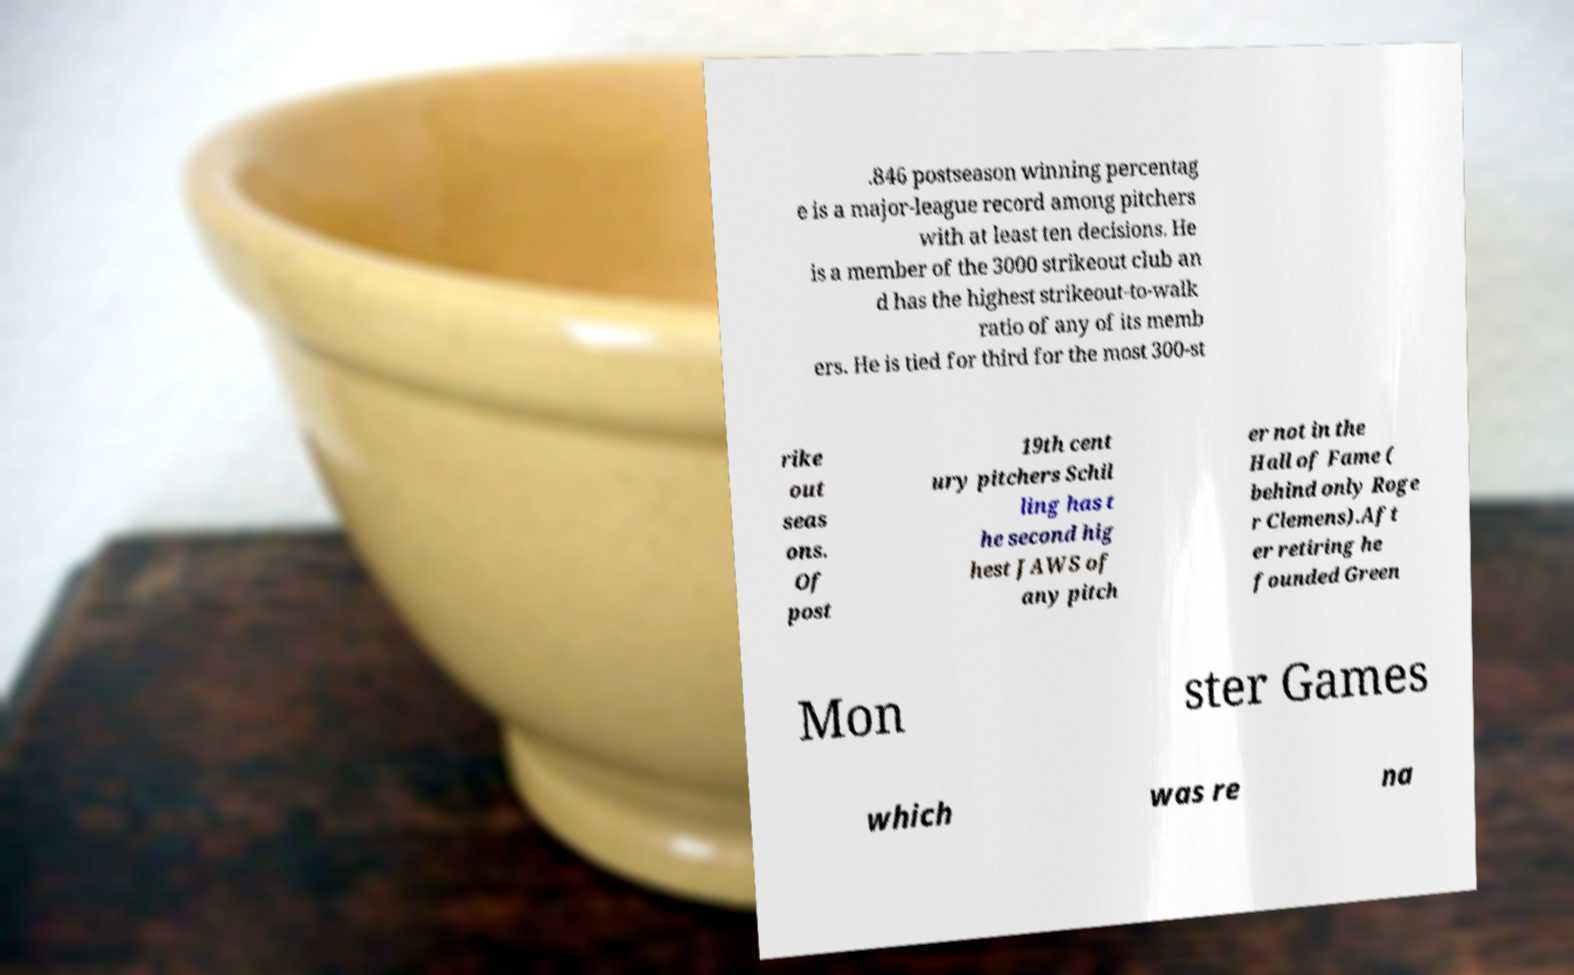Can you read and provide the text displayed in the image?This photo seems to have some interesting text. Can you extract and type it out for me? .846 postseason winning percentag e is a major-league record among pitchers with at least ten decisions. He is a member of the 3000 strikeout club an d has the highest strikeout-to-walk ratio of any of its memb ers. He is tied for third for the most 300-st rike out seas ons. Of post 19th cent ury pitchers Schil ling has t he second hig hest JAWS of any pitch er not in the Hall of Fame ( behind only Roge r Clemens).Aft er retiring he founded Green Mon ster Games which was re na 